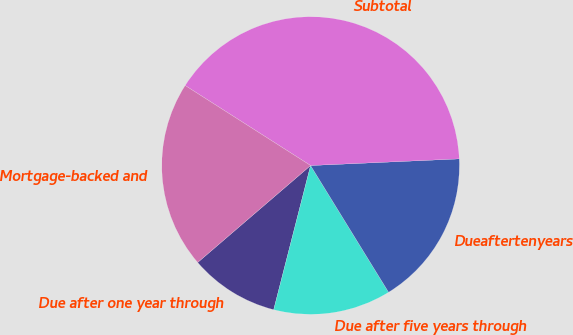<chart> <loc_0><loc_0><loc_500><loc_500><pie_chart><fcel>Due after one year through<fcel>Due after five years through<fcel>Dueaftertenyears<fcel>Subtotal<fcel>Mortgage-backed and<nl><fcel>9.72%<fcel>12.77%<fcel>16.93%<fcel>40.25%<fcel>20.33%<nl></chart> 